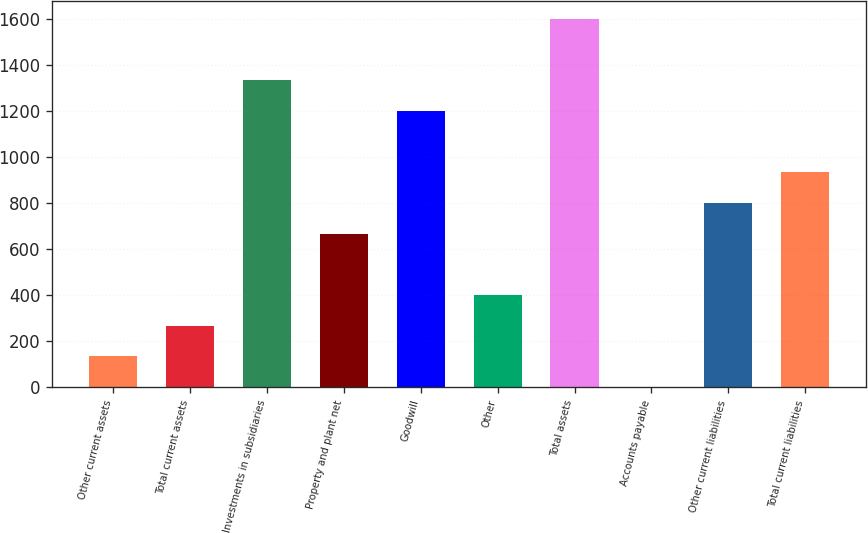Convert chart. <chart><loc_0><loc_0><loc_500><loc_500><bar_chart><fcel>Other current assets<fcel>Total current assets<fcel>Investments in subsidiaries<fcel>Property and plant net<fcel>Goodwill<fcel>Other<fcel>Total assets<fcel>Accounts payable<fcel>Other current liabilities<fcel>Total current liabilities<nl><fcel>134.3<fcel>267.6<fcel>1334<fcel>667.5<fcel>1200.7<fcel>400.9<fcel>1600.6<fcel>1<fcel>800.8<fcel>934.1<nl></chart> 